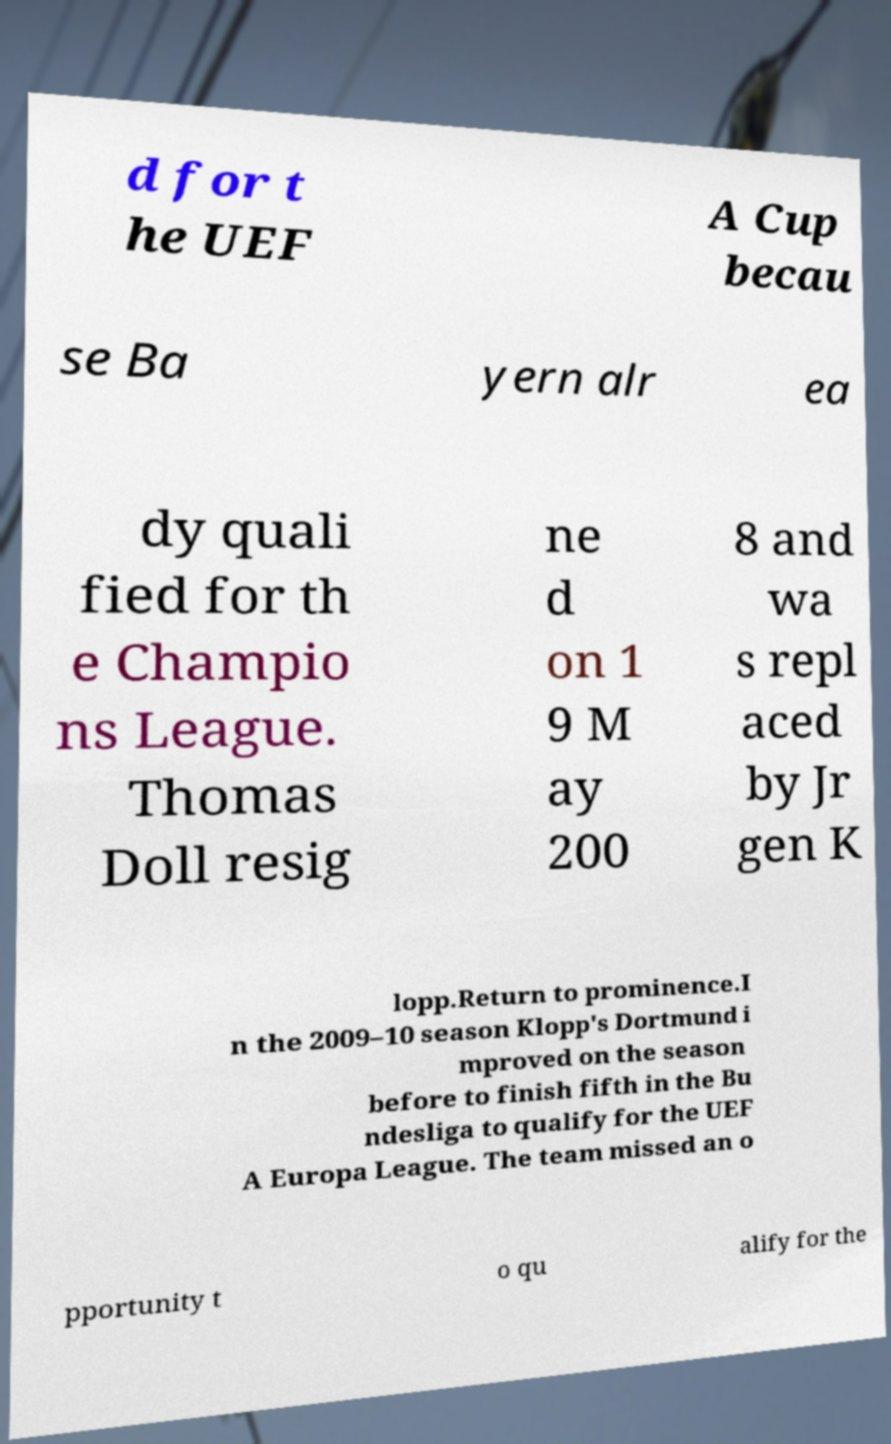What messages or text are displayed in this image? I need them in a readable, typed format. d for t he UEF A Cup becau se Ba yern alr ea dy quali fied for th e Champio ns League. Thomas Doll resig ne d on 1 9 M ay 200 8 and wa s repl aced by Jr gen K lopp.Return to prominence.I n the 2009–10 season Klopp's Dortmund i mproved on the season before to finish fifth in the Bu ndesliga to qualify for the UEF A Europa League. The team missed an o pportunity t o qu alify for the 